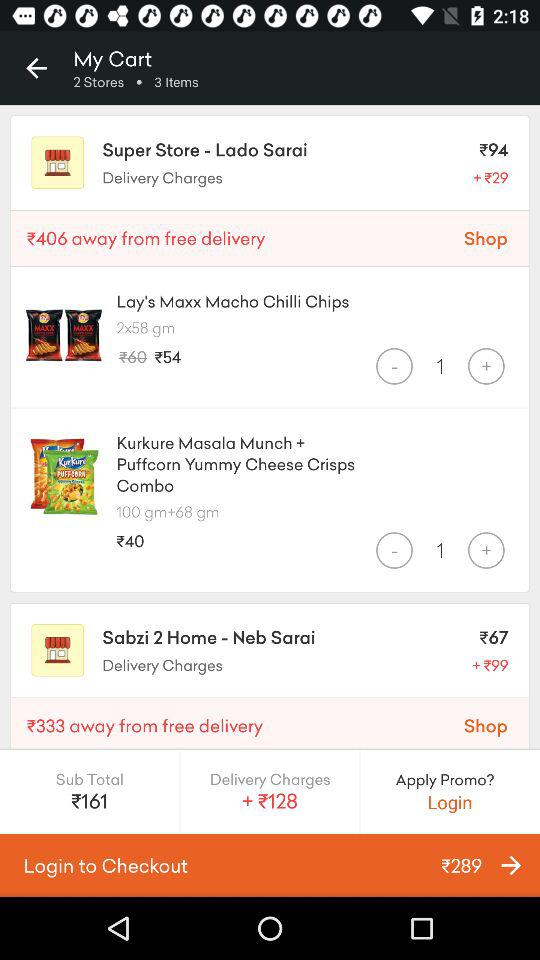What is the price of Lay's Maxx Macho Chilli Chips? The price is 54 rupees. 